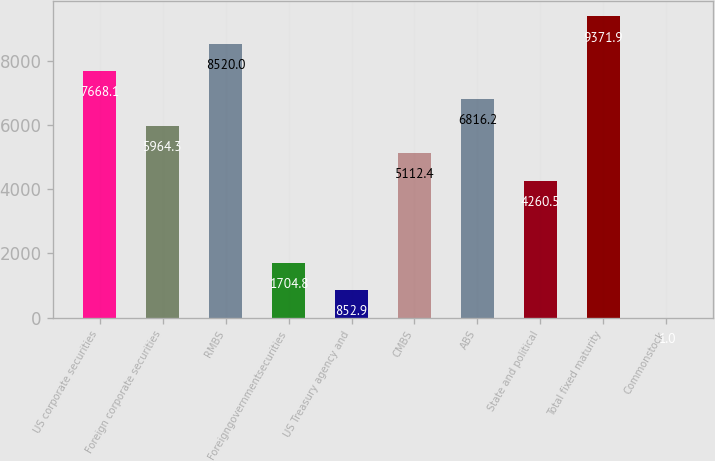<chart> <loc_0><loc_0><loc_500><loc_500><bar_chart><fcel>US corporate securities<fcel>Foreign corporate securities<fcel>RMBS<fcel>Foreigngovernmentsecurities<fcel>US Treasury agency and<fcel>CMBS<fcel>ABS<fcel>State and political<fcel>Total fixed maturity<fcel>Commonstock<nl><fcel>7668.1<fcel>5964.3<fcel>8520<fcel>1704.8<fcel>852.9<fcel>5112.4<fcel>6816.2<fcel>4260.5<fcel>9371.9<fcel>1<nl></chart> 